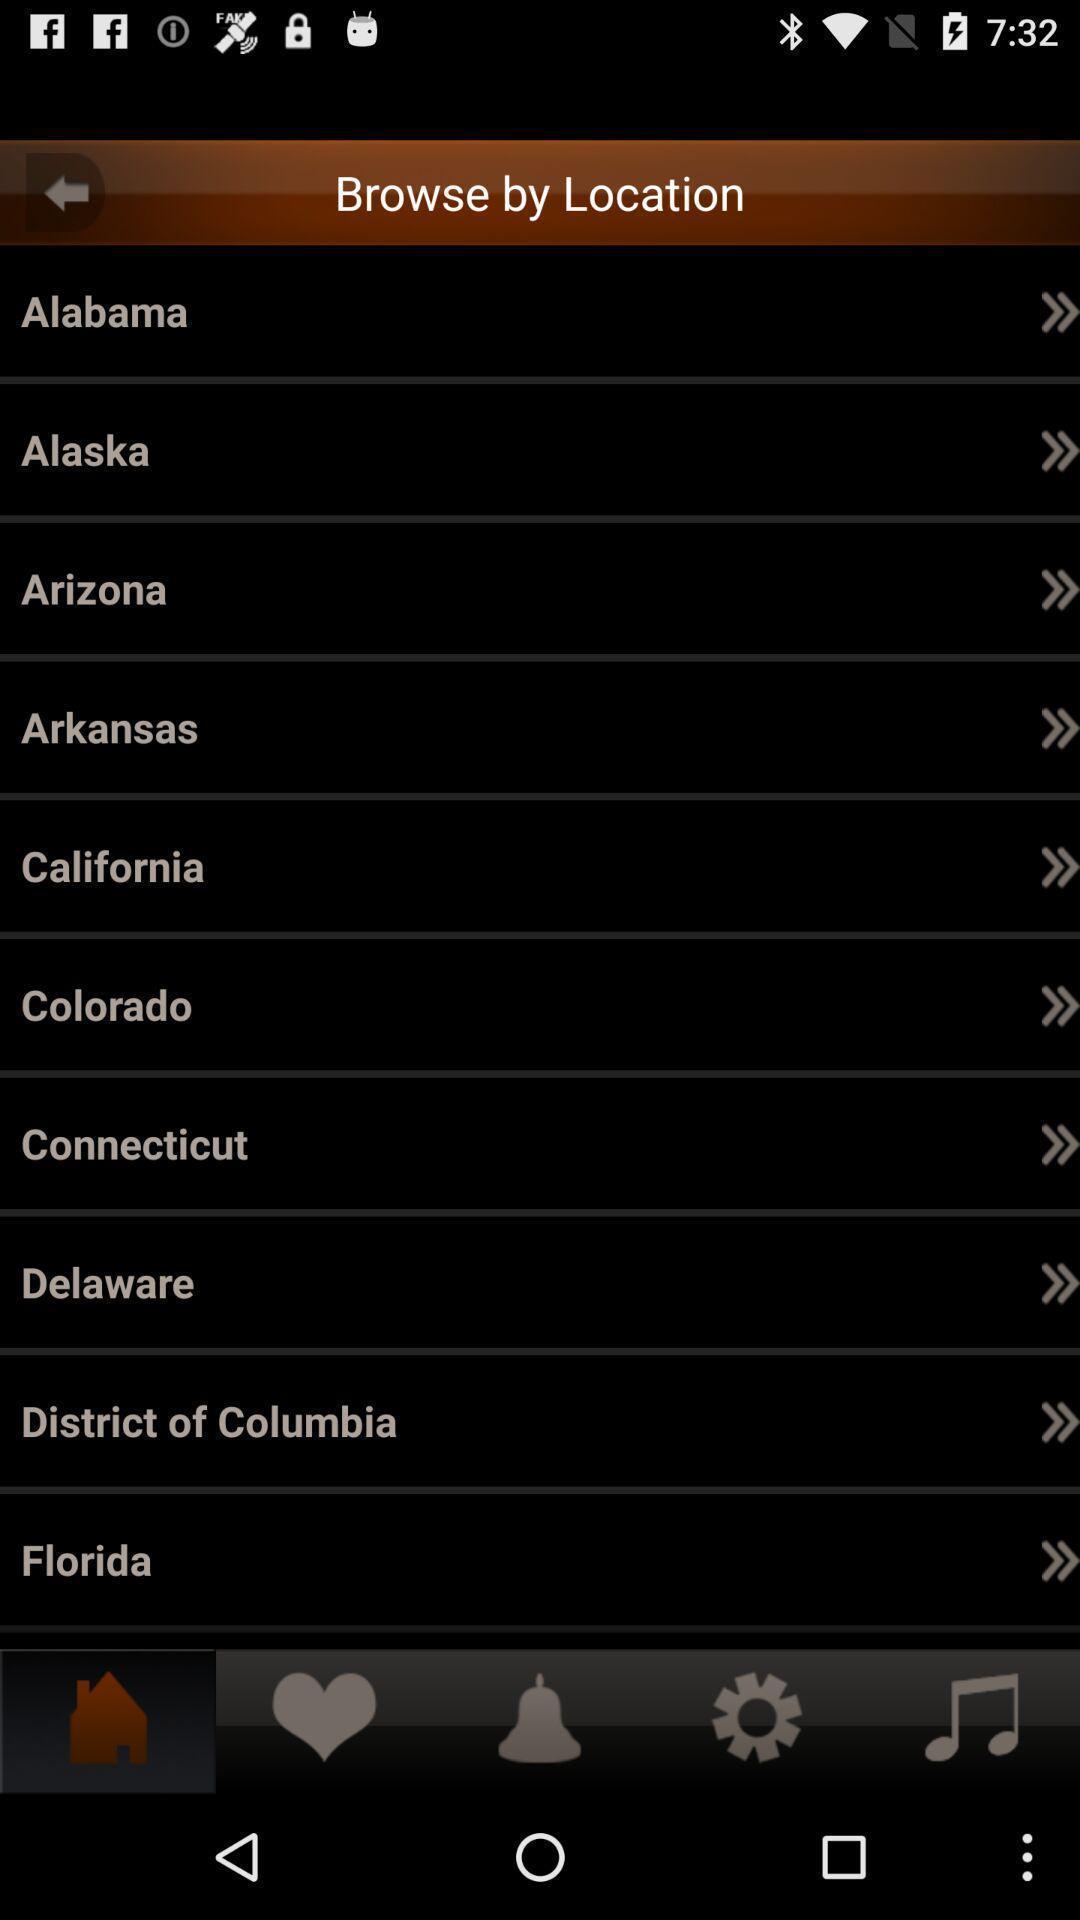Tell me what you see in this picture. Page showing list of various locations. 